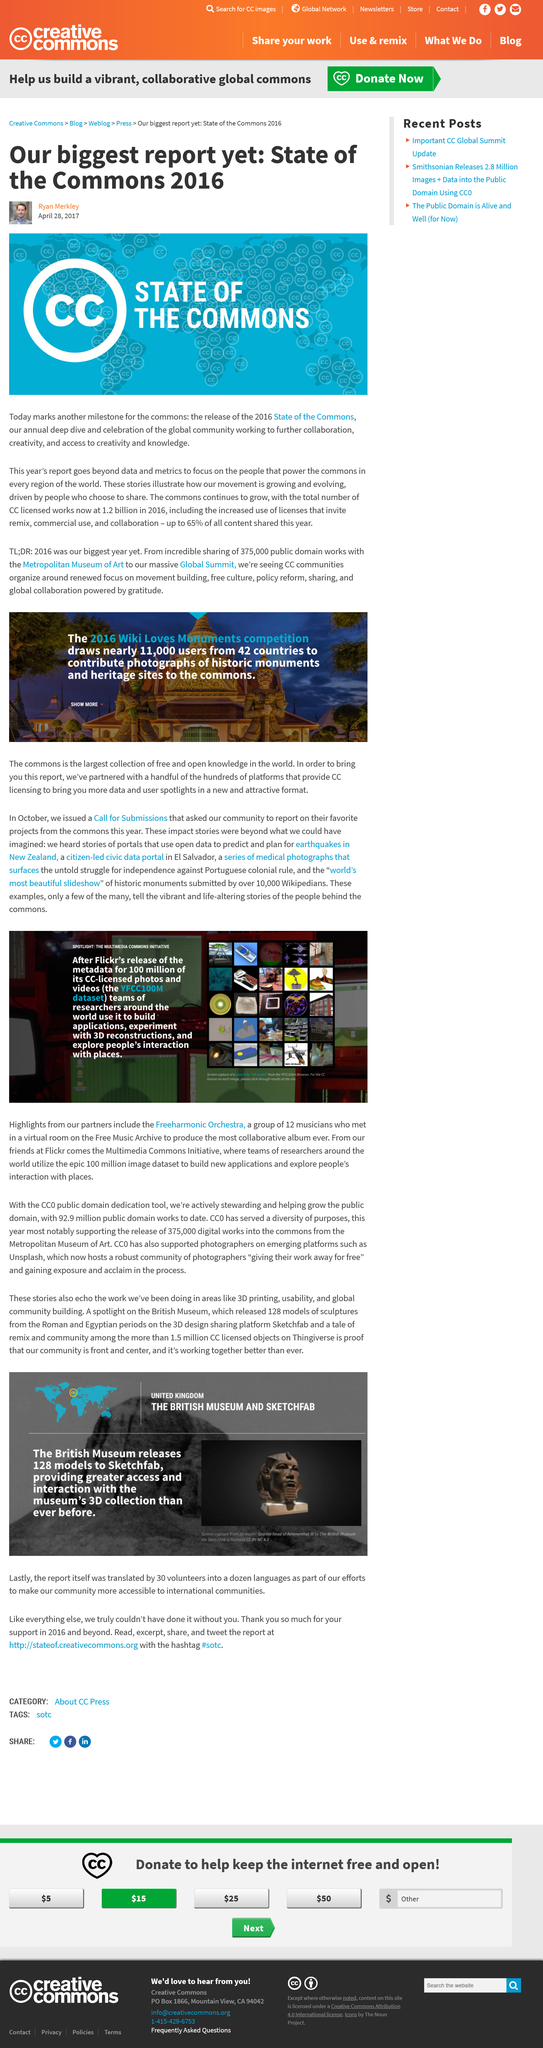Point out several critical features in this image. The CCO public domain dedication tool utilizes the YFCC100M dataset. The Metropolitan Museum of Art has made 375,000 digital works available for public use. The British Museum, located in the United Kingdom, is home to a vast collection of artifacts and historical objects from around the world. Additionally, The United Kingdom is also the home of Sketchfab, a platform for 3D content creation and sharing. The report was translated into a dozen languages. The 2016 State of the Commons report was released on that day. 